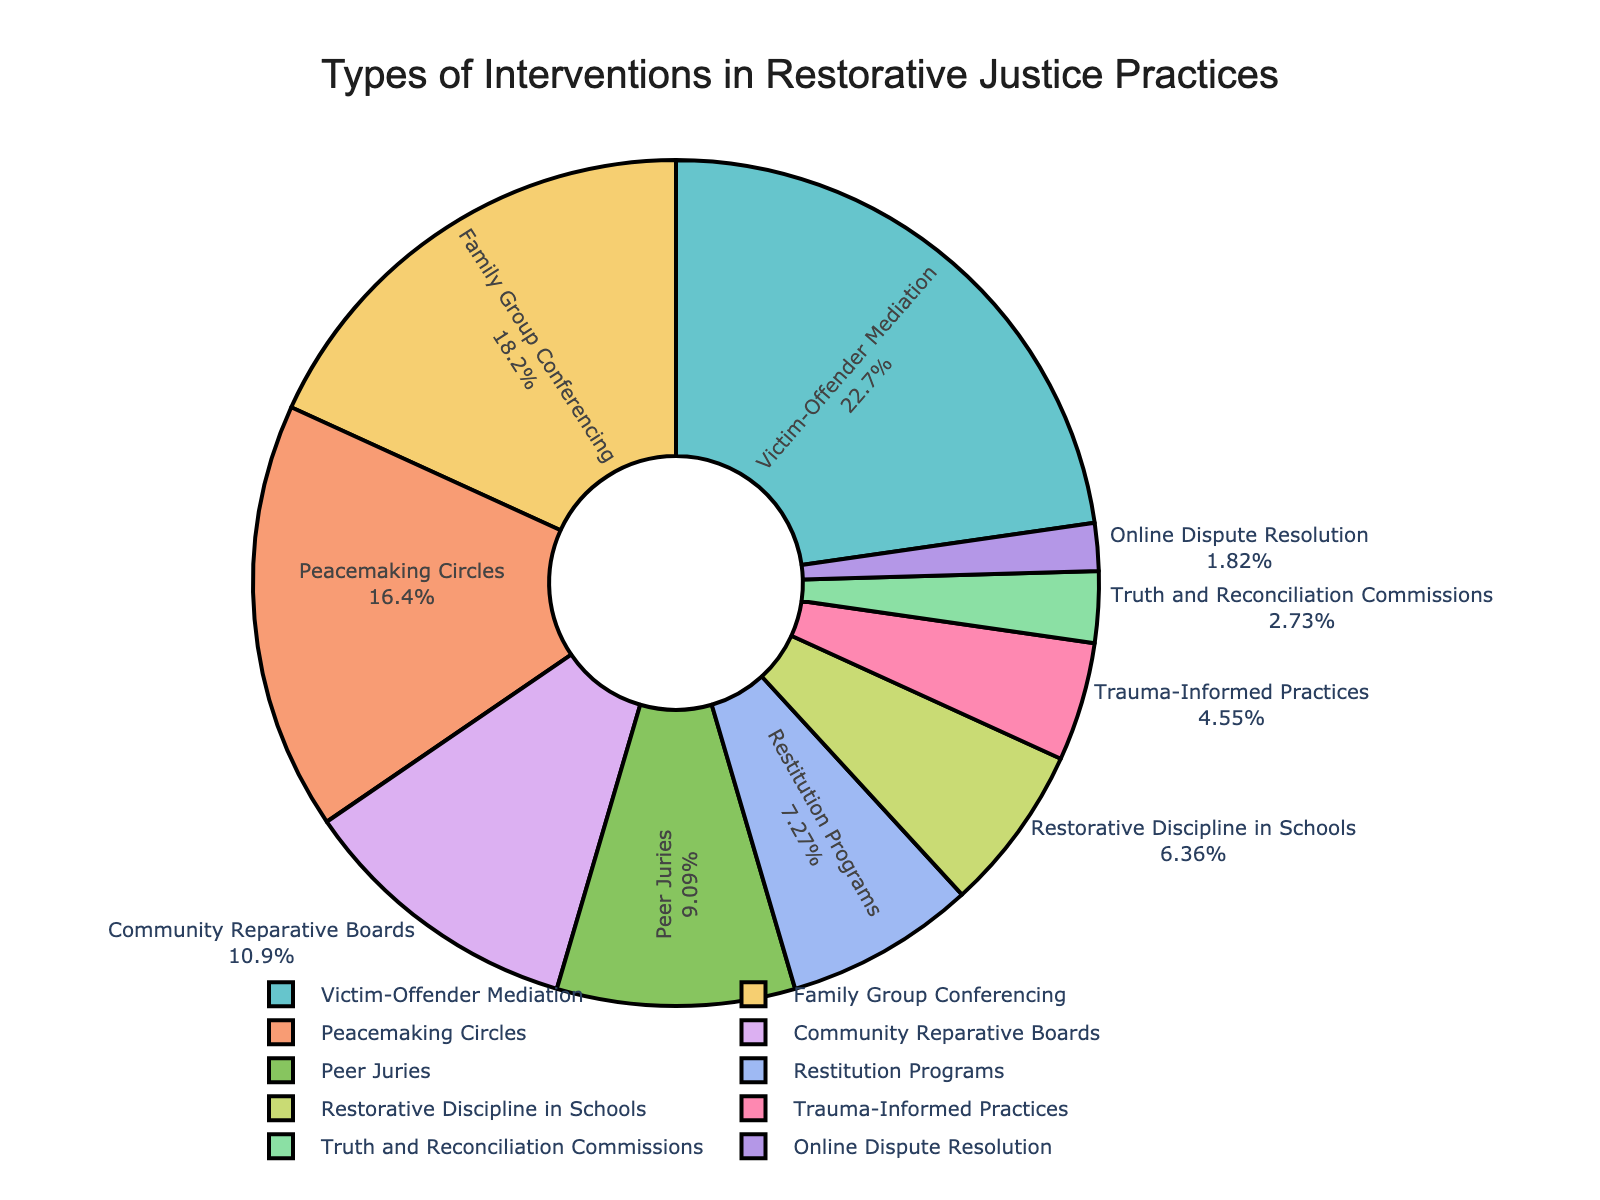What is the most commonly used intervention in restorative justice practices? By observing the pie chart, we can see that the largest segment represents Victim-Offender Mediation. This suggests it is the most commonly used intervention, as it occupies the largest portion of the pie.
Answer: Victim-Offender Mediation Which intervention type is used more, Family Group Conferencing or Restorative Discipline in Schools? The pie chart shows that Family Group Conferencing has a larger segment compared to Restorative Discipline in Schools. Family Group Conferencing is 20%, while Restorative Discipline in Schools is 7%.
Answer: Family Group Conferencing What is the combined percentage of Peacemaking Circles and Community Reparative Boards? To find the combined percentage, we add the percentages of Peacemaking Circles and Community Reparative Boards. Peacemaking Circles is 18% and Community Reparative Boards is 12%, so 18% + 12% = 30%.
Answer: 30% Which intervention type has the smallest representation in the pie chart? By inspecting the pie chart, the smallest segment corresponds to the Online Dispute Resolution, which has the smallest percentage.
Answer: Online Dispute Resolution Are Peer Juries more commonly used than Restitution Programs? From the pie chart, we see that Peer Juries represents 10% while Restitution Programs represents 8%. Since 10% is greater than 8%, Peer Juries are more commonly used than Restitution Programs.
Answer: Yes How does the percentage of Trauma-Informed Practices compare to that of Restorative Discipline in Schools? The pie chart shows that Trauma-Informed Practices is 5% and Restorative Discipline in Schools is 7%. Since 5% is less than 7%, Trauma-Informed Practices is used less than Restorative Discipline in Schools.
Answer: Trauma-Informed Practices is less What percentage of the interventions are used by the top three most common types? The top three most common types are Victim-Offender Mediation (25%), Family Group Conferencing (20%), and Peacemaking Circles (18%). Adding these together, 25% + 20% + 18% = 63%.
Answer: 63% What is the difference in percentage between Community Reparative Boards and Trauma-Informed Practices? To find the difference, subtract the percentage of Trauma-Informed Practices (5%) from Community Reparative Boards (12%). Thus, 12% - 5% = 7%.
Answer: 7% Compare the combined percentage of the two least common interventions to the Peacemaking Circles. The two least common interventions are Online Dispute Resolution (2%) and Truth and Reconciliation Commissions (3%). Their combined percentage is 2% + 3% = 5%. Peacemaking Circles is 18%. Since 5% is less than 18%, the combined percentage is less than Peacemaking Circles.
Answer: Combined is less 